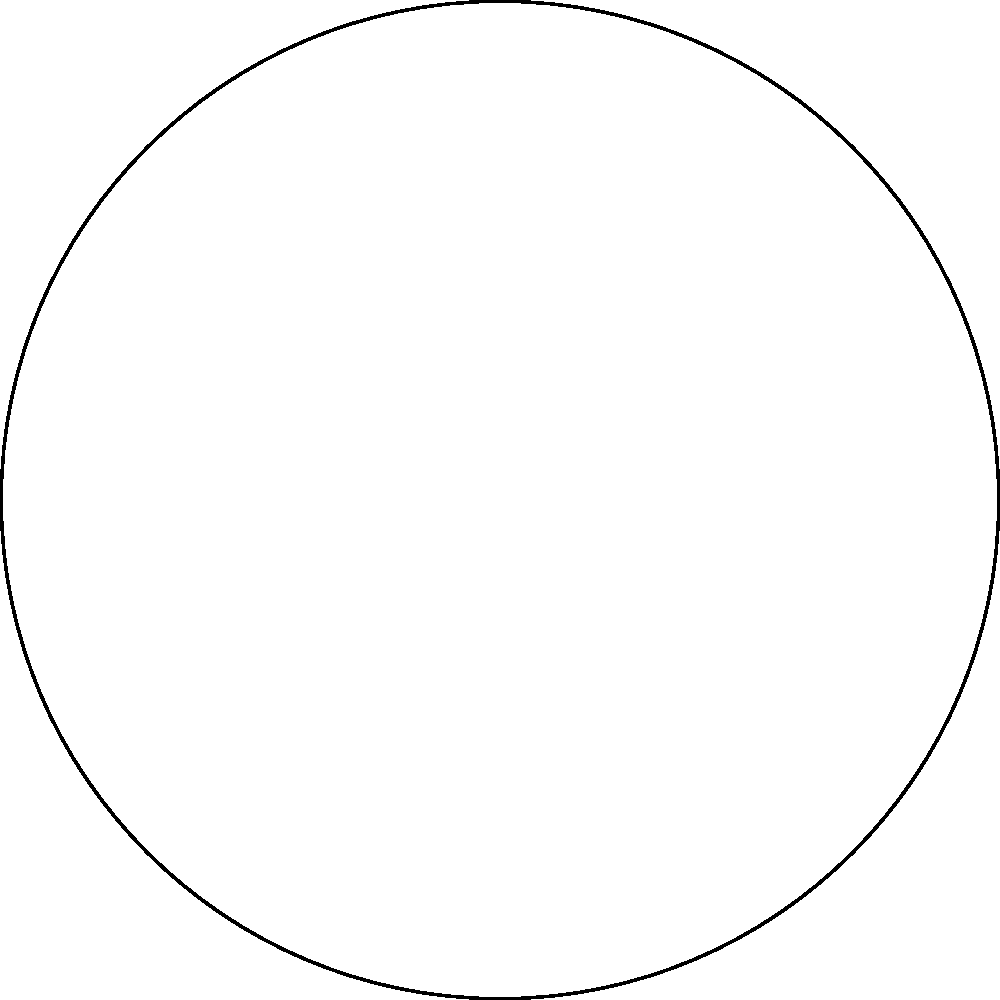At a circular Judy Collins concert venue, seats are arranged in a polar coordinate system. The radius of the venue is 50 meters, and there are 8 sections numbered clockwise from 1 to 8. If you're seated in section 6 at a radius of 30 meters, what are your seat's polar coordinates $(r,\theta)$? To find the polar coordinates of the seat, we need to determine both the radius (r) and the angle (θ).

1. Radius (r):
   The radius is given in the question as 30 meters.
   $r = 30$ meters

2. Angle (θ):
   - There are 8 sections in total, equally spaced around the circle.
   - Each section covers an angle of $\frac{360°}{8} = 45°$ or $\frac{\pi}{4}$ radians.
   - Section 6 starts at an angle of $5 \times 45° = 225°$ or $5\pi/4$ radians.

   To find the angle to the middle of section 6:
   $\theta = 225° + \frac{45°}{2} = 247.5°$
   
   Converting to radians:
   $\theta = 247.5° \times \frac{\pi}{180°} = \frac{11\pi}{8}$ radians

Therefore, the polar coordinates of the seat are $(30, \frac{11\pi}{8})$.
Answer: $(30, \frac{11\pi}{8})$ 